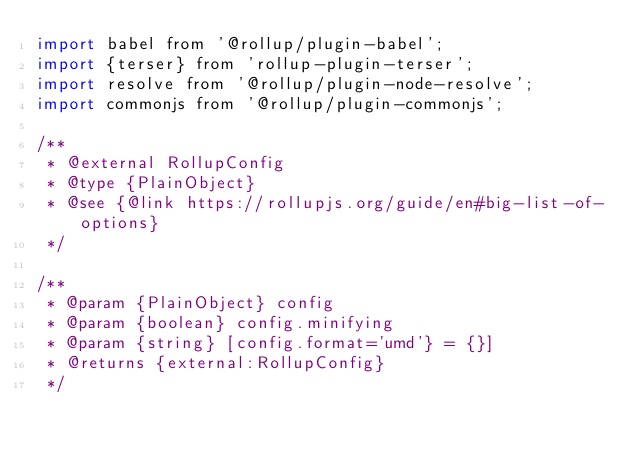<code> <loc_0><loc_0><loc_500><loc_500><_JavaScript_>import babel from '@rollup/plugin-babel';
import {terser} from 'rollup-plugin-terser';
import resolve from '@rollup/plugin-node-resolve';
import commonjs from '@rollup/plugin-commonjs';

/**
 * @external RollupConfig
 * @type {PlainObject}
 * @see {@link https://rollupjs.org/guide/en#big-list-of-options}
 */

/**
 * @param {PlainObject} config
 * @param {boolean} config.minifying
 * @param {string} [config.format='umd'} = {}]
 * @returns {external:RollupConfig}
 */</code> 